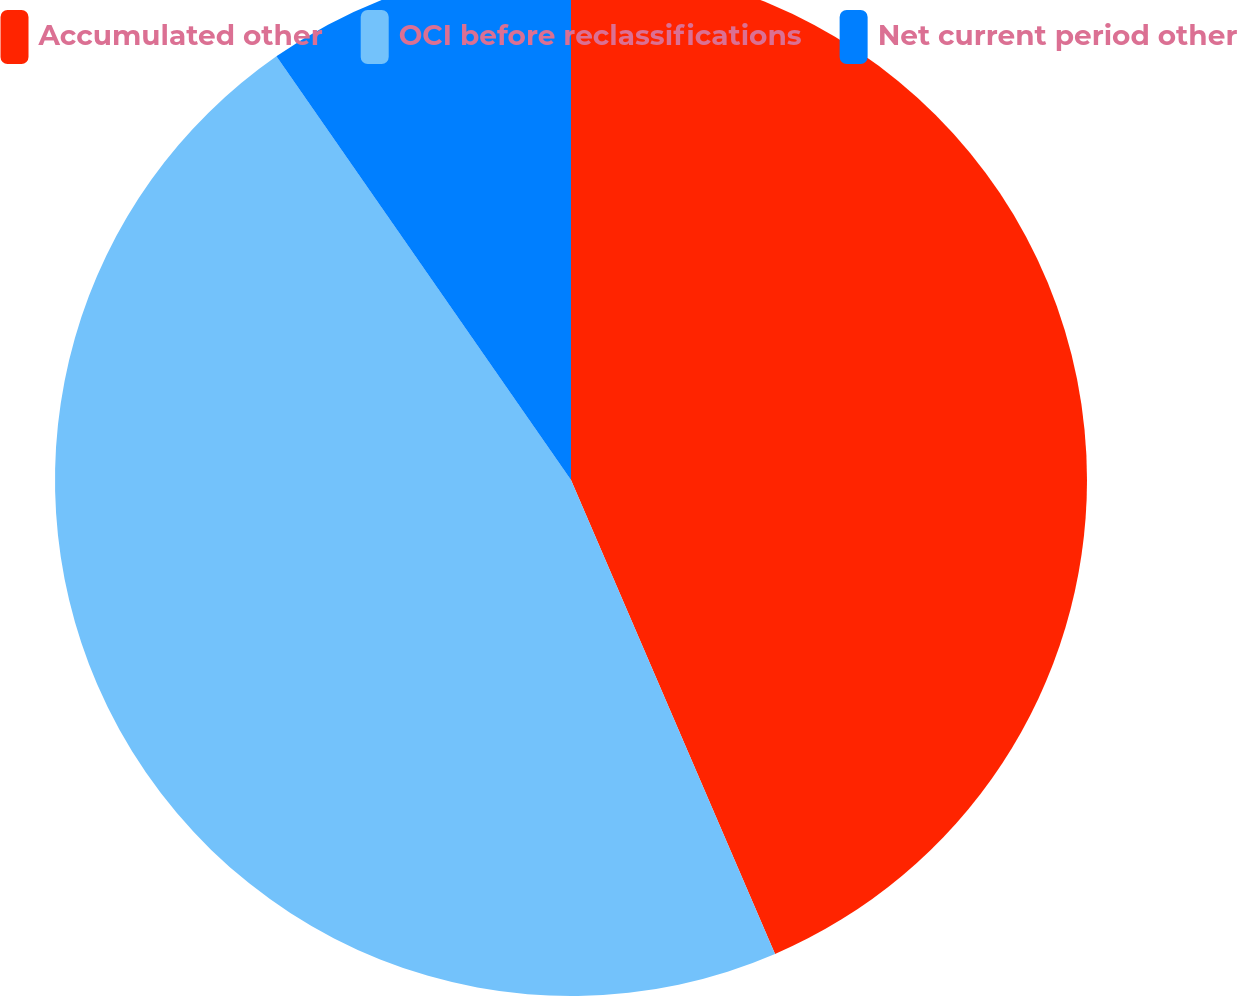Convert chart. <chart><loc_0><loc_0><loc_500><loc_500><pie_chart><fcel>Accumulated other<fcel>OCI before reclassifications<fcel>Net current period other<nl><fcel>43.53%<fcel>46.8%<fcel>9.67%<nl></chart> 